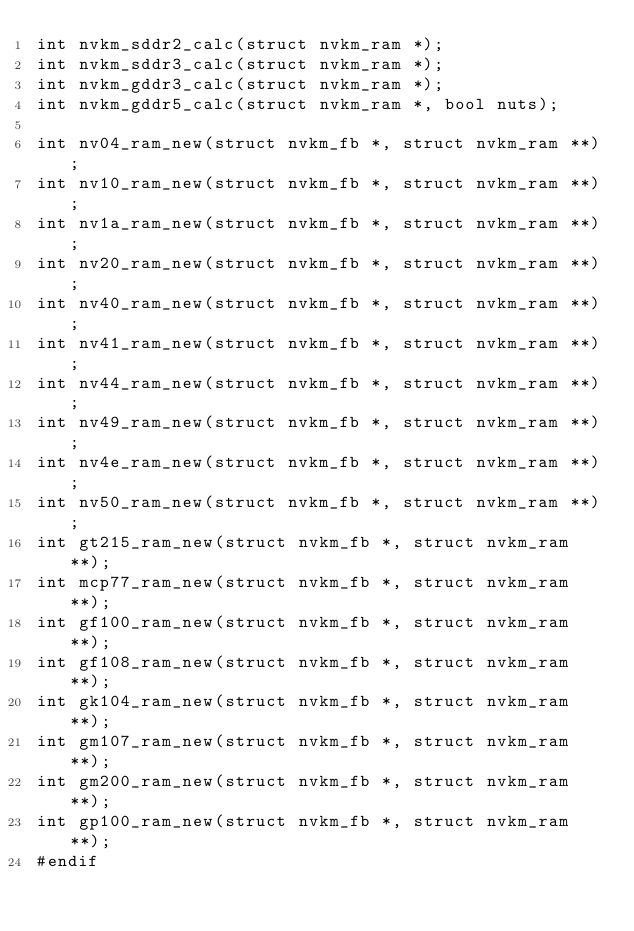<code> <loc_0><loc_0><loc_500><loc_500><_C_>int nvkm_sddr2_calc(struct nvkm_ram *);
int nvkm_sddr3_calc(struct nvkm_ram *);
int nvkm_gddr3_calc(struct nvkm_ram *);
int nvkm_gddr5_calc(struct nvkm_ram *, bool nuts);

int nv04_ram_new(struct nvkm_fb *, struct nvkm_ram **);
int nv10_ram_new(struct nvkm_fb *, struct nvkm_ram **);
int nv1a_ram_new(struct nvkm_fb *, struct nvkm_ram **);
int nv20_ram_new(struct nvkm_fb *, struct nvkm_ram **);
int nv40_ram_new(struct nvkm_fb *, struct nvkm_ram **);
int nv41_ram_new(struct nvkm_fb *, struct nvkm_ram **);
int nv44_ram_new(struct nvkm_fb *, struct nvkm_ram **);
int nv49_ram_new(struct nvkm_fb *, struct nvkm_ram **);
int nv4e_ram_new(struct nvkm_fb *, struct nvkm_ram **);
int nv50_ram_new(struct nvkm_fb *, struct nvkm_ram **);
int gt215_ram_new(struct nvkm_fb *, struct nvkm_ram **);
int mcp77_ram_new(struct nvkm_fb *, struct nvkm_ram **);
int gf100_ram_new(struct nvkm_fb *, struct nvkm_ram **);
int gf108_ram_new(struct nvkm_fb *, struct nvkm_ram **);
int gk104_ram_new(struct nvkm_fb *, struct nvkm_ram **);
int gm107_ram_new(struct nvkm_fb *, struct nvkm_ram **);
int gm200_ram_new(struct nvkm_fb *, struct nvkm_ram **);
int gp100_ram_new(struct nvkm_fb *, struct nvkm_ram **);
#endif
</code> 